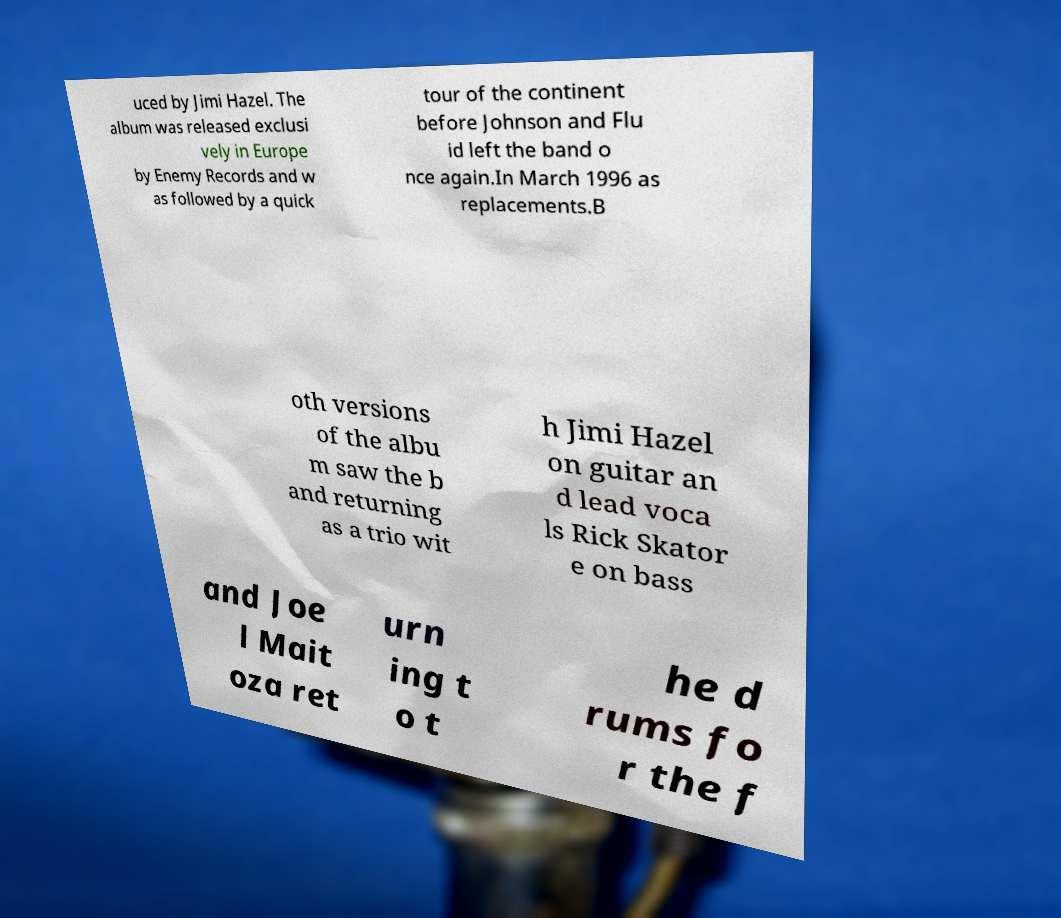Could you assist in decoding the text presented in this image and type it out clearly? uced by Jimi Hazel. The album was released exclusi vely in Europe by Enemy Records and w as followed by a quick tour of the continent before Johnson and Flu id left the band o nce again.In March 1996 as replacements.B oth versions of the albu m saw the b and returning as a trio wit h Jimi Hazel on guitar an d lead voca ls Rick Skator e on bass and Joe l Mait oza ret urn ing t o t he d rums fo r the f 